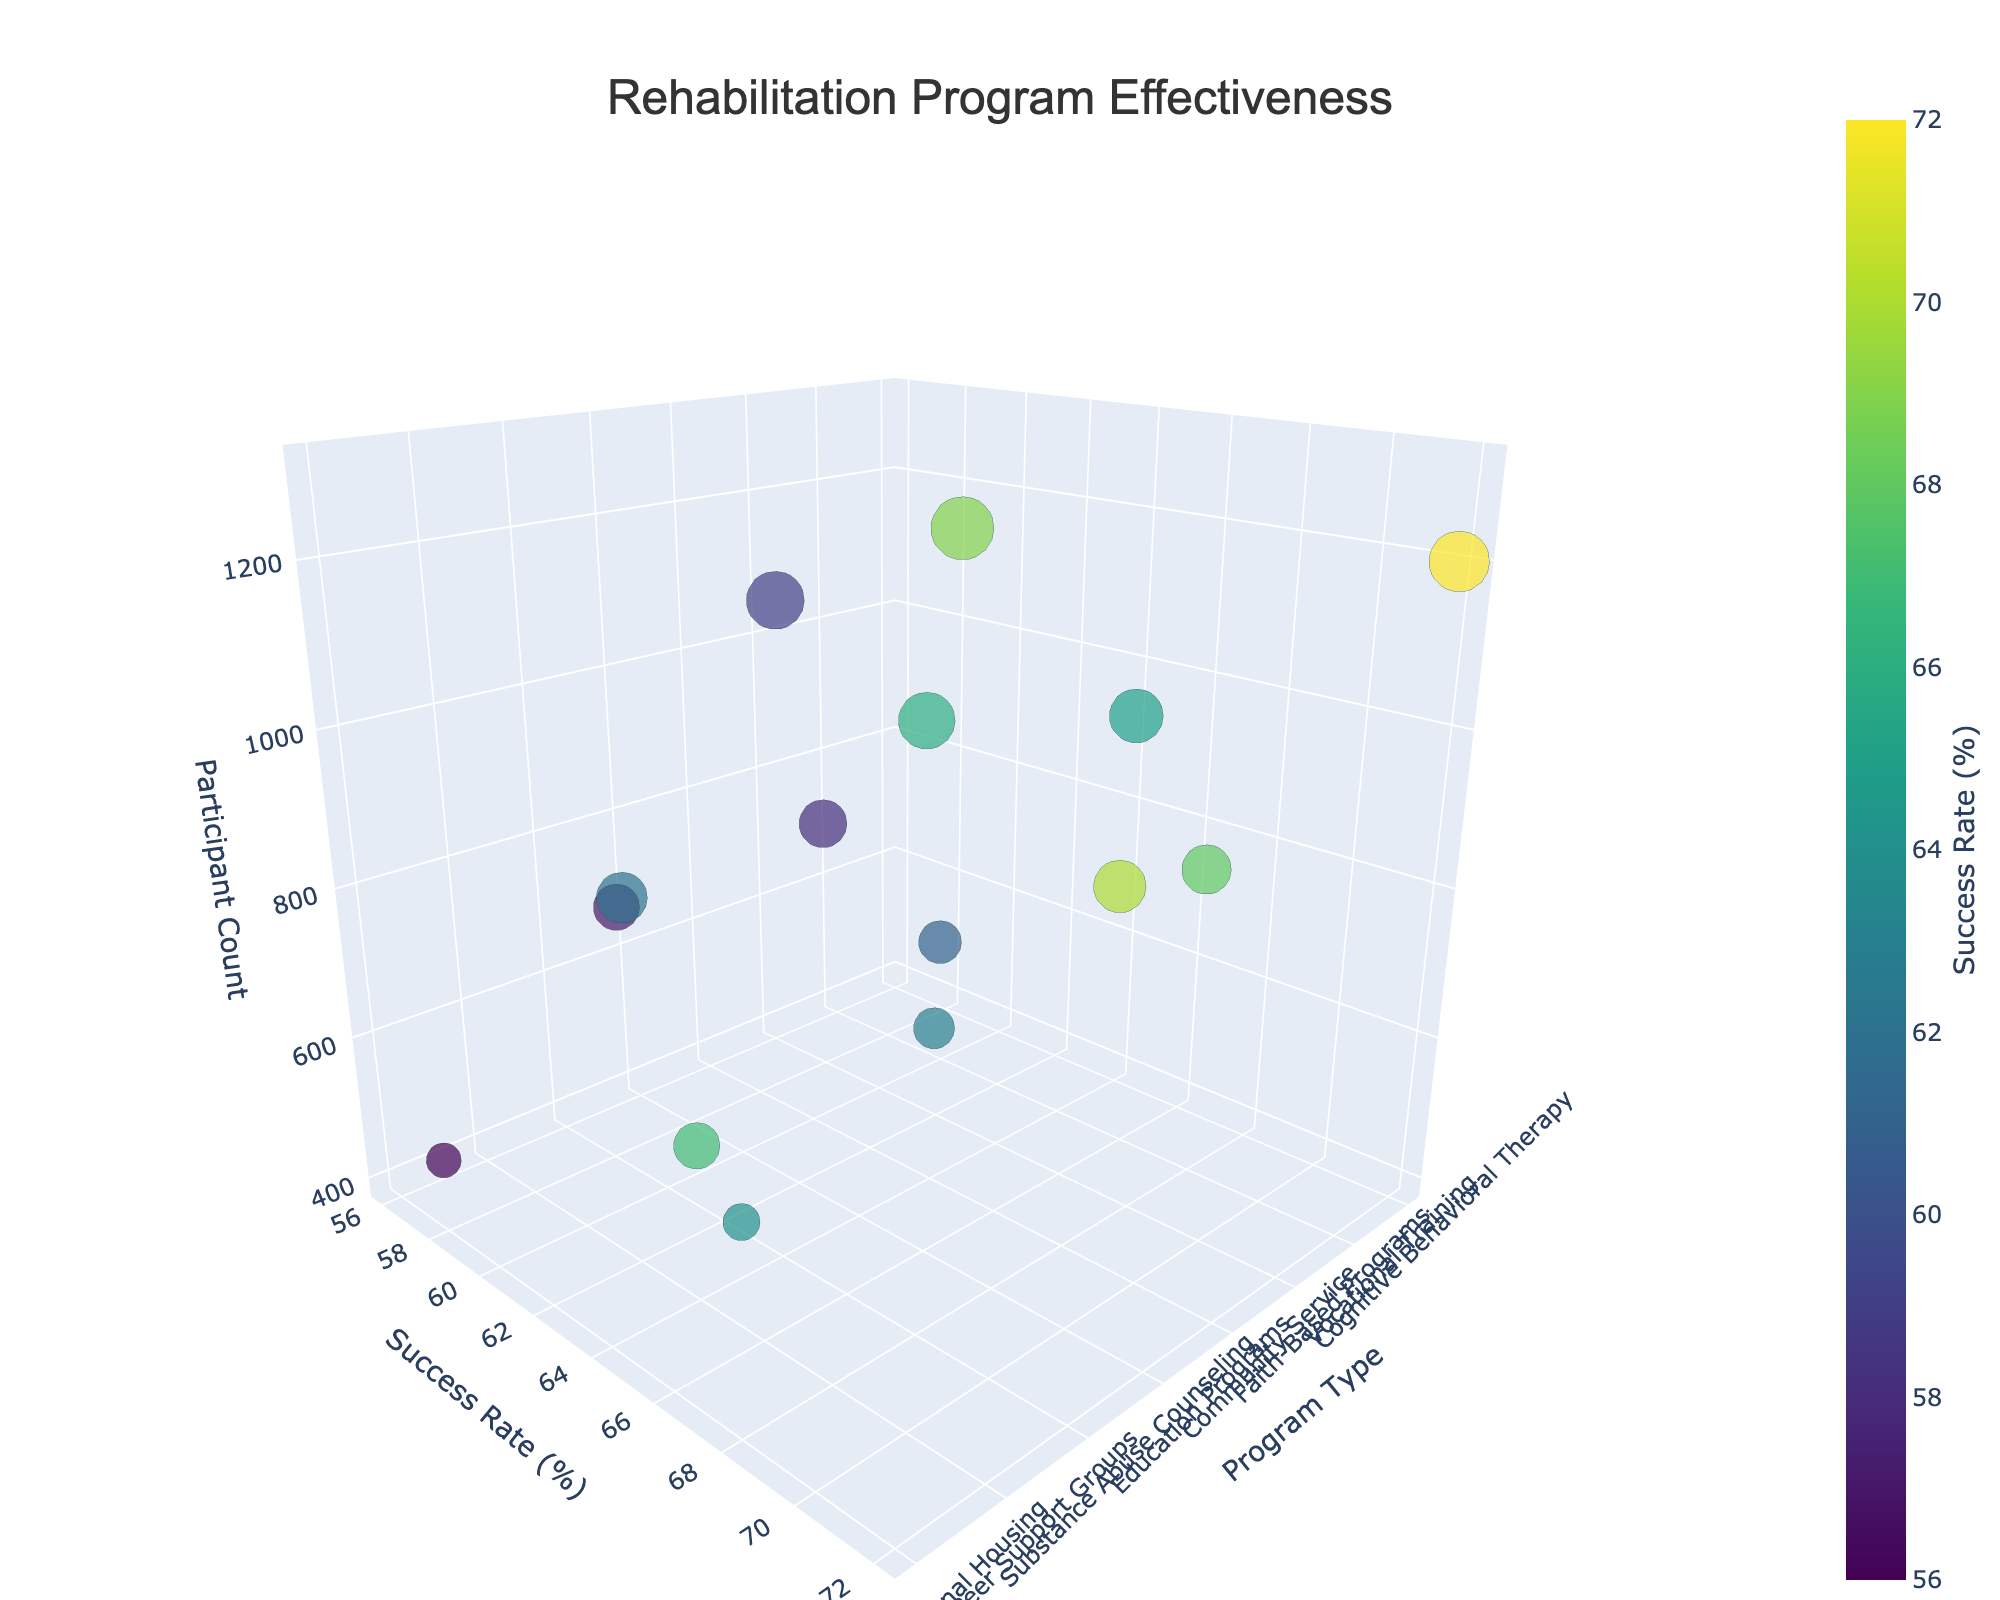What is the title of the figure? The title is clearly shown at the top of the figure.
Answer: Rehabilitation Program Effectiveness What are the axis labels on the 3D bubble chart? The axis labels are the names of each axis.
Answer: Program Type, Success Rate (%), Participant Count How many data points are represented in the chart? Each bubble represents a data point, so counting the bubbles gives the number of data points.
Answer: 15 Which rehabilitation program has the highest success rate? Locate the highest value on the Success Rate axis and find the corresponding bubble.
Answer: Cognitive Behavioral Therapy Which program has the smallest participant count? Locate the smallest value on the Participant Count axis and find the corresponding bubble.
Answer: Art Therapy What is the success rate for Vocational Training? Locate the bubble for Vocational Training and read the success rate from the y-axis.
Answer: 68% Which program has more participants: Drug Courts or Education Programs? Compare the participant count for the bubbles representing Drug Courts and Education Programs.
Answer: Education Programs What is the average success rate of Mindfulness-Based Stress Reduction and Peer Support Groups? Find the success rates of both programs and calculate the average: (61 + 62) / 2 = 61.5
Answer: 61.5% Which program has a higher success rate: Family Reunification or Faith-Based Programs? Compare the success rates of the bubbles for Family Reunification and Faith-Based Programs.
Answer: Family Reunification How does the success rate of Substance Abuse Counseling compare to Mental Health Treatment? Compare the success rates of both bubbles to see which one is greater.
Answer: Mental Health Treatment 